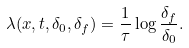Convert formula to latex. <formula><loc_0><loc_0><loc_500><loc_500>\lambda ( { x } , t , \delta _ { 0 } , \delta _ { f } ) = \frac { 1 } { \tau } \log \frac { \delta _ { f } } { \delta _ { 0 } } .</formula> 